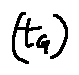<formula> <loc_0><loc_0><loc_500><loc_500>( t _ { G } )</formula> 